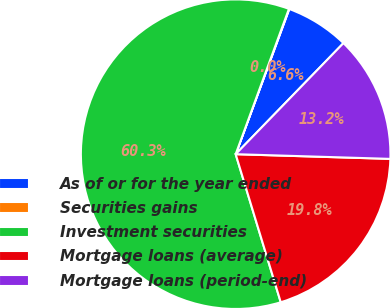Convert chart to OTSL. <chart><loc_0><loc_0><loc_500><loc_500><pie_chart><fcel>As of or for the year ended<fcel>Securities gains<fcel>Investment securities<fcel>Mortgage loans (average)<fcel>Mortgage loans (period-end)<nl><fcel>6.63%<fcel>0.04%<fcel>60.29%<fcel>19.81%<fcel>13.22%<nl></chart> 